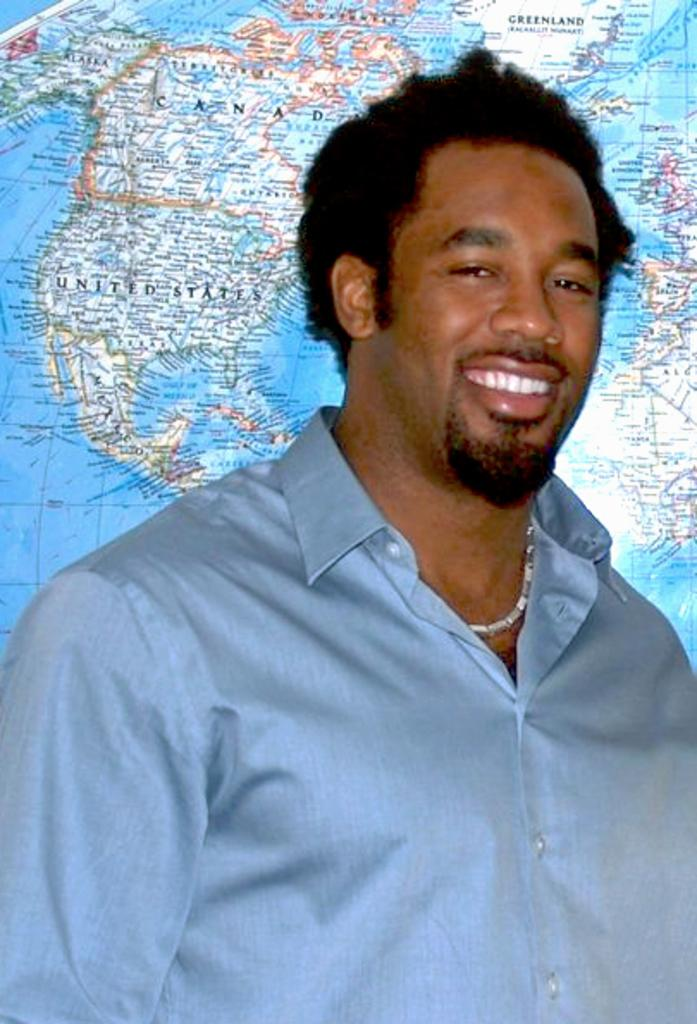Who is the main subject in the image? There is a man in the center of the image. What is the man wearing? The man is wearing a chain. What is the man's facial expression? The man is smiling. What can be seen in the background of the image? There is a globe in the background of the image. What type of treatment is the man receiving in the image? There is no indication in the image that the man is receiving any treatment; he is simply standing and smiling. What kind of pipe can be seen in the image? There is no pipe present in the image. 